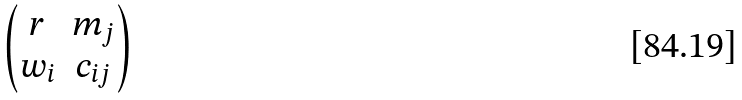<formula> <loc_0><loc_0><loc_500><loc_500>\begin{pmatrix} r & m _ { j } \\ w _ { i } & c _ { i j } \end{pmatrix}</formula> 